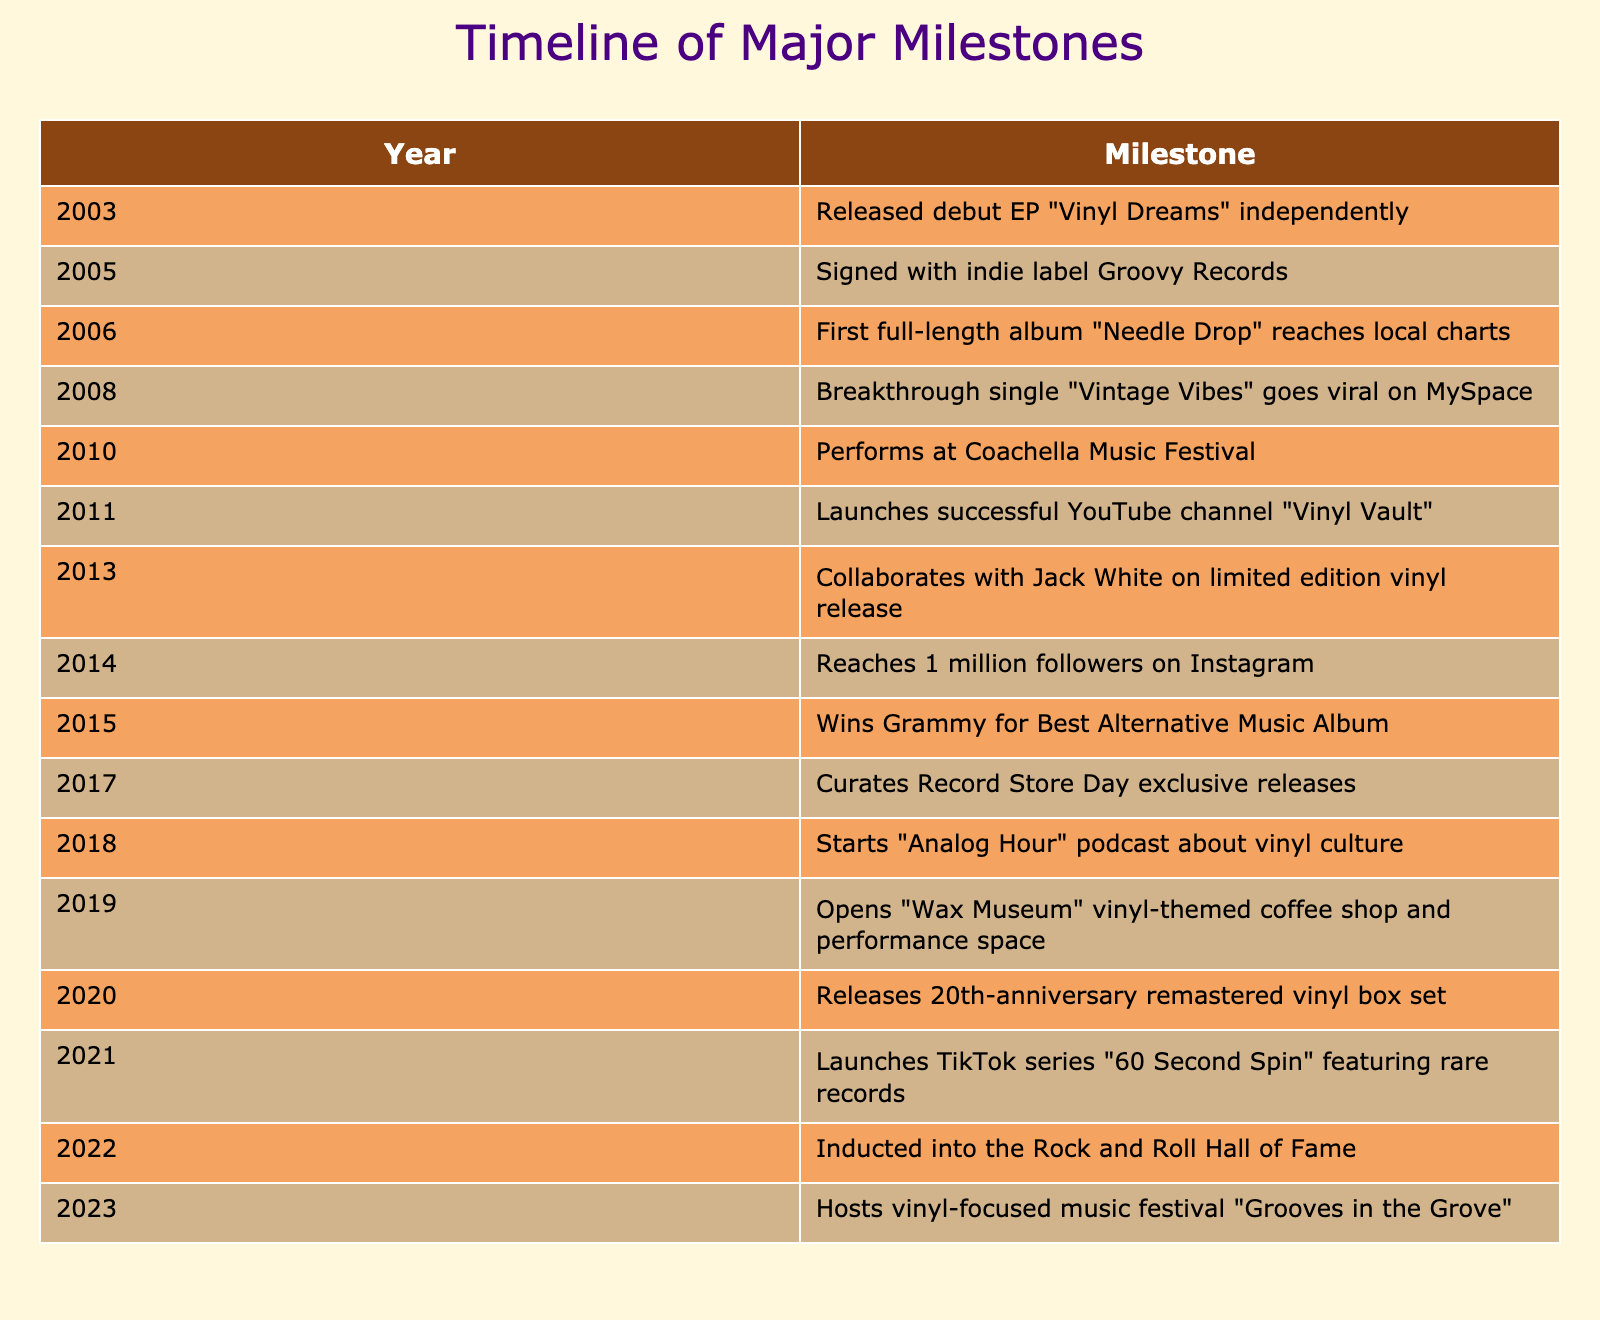What year did the musician release their debut EP? The debut EP "Vinyl Dreams" was released in 2003.
Answer: 2003 What milestone occurred in 2015? The milestone in 2015 was winning a Grammy for Best Alternative Music Album.
Answer: Wins Grammy for Best Alternative Music Album How many years passed between the release of the first full-length album and the breakthrough single? The first full-length album "Needle Drop" was released in 2006, and the breakthrough single "Vintage Vibes" was released in 2008, which is 2 years apart.
Answer: 2 years Did the musician perform at Coachella before or after launching their YouTube channel? The musician performed at Coachella in 2010 and launched their YouTube channel in 2011, meaning the performance was before the channel launch.
Answer: Before What is the average number of milestones recorded per five-year period from 2003 to 2023? The total number of milestones is 14, and the span from 2003 to 2023 is 20 years, or 4 five-year periods. Dividing 14 by 4 gives us an average of 3.5 milestones per five-year period.
Answer: 3.5 milestones What was the last milestone achieved in the timeline? The last milestone recorded is hosting the vinyl-focused music festival "Grooves in the Grove" in 2023.
Answer: Hosts vinyl-focused music festival "Grooves in the Grove" How many times did the musician achieve milestones related to vinyl records specifically? The milestones related to vinyl records include the launch of the YouTube channel "Vinyl Vault," the collaboration on a limited edition vinyl release with Jack White, and the release of the 20th-anniversary remastered vinyl box set, totaling 3 milestones.
Answer: 3 milestones Which year marks the musician's induction into the Rock and Roll Hall of Fame? The year of induction into the Rock and Roll Hall of Fame is 2022.
Answer: 2022 What was the first milestone to achieve a significant recognition on social media? The first milestone that reflected significant recognition on social media was reaching 1 million followers on Instagram in 2014, which indicates a growing online presence before launching the TikTok series in 2021.
Answer: Reaches 1 million followers on Instagram in 2014 